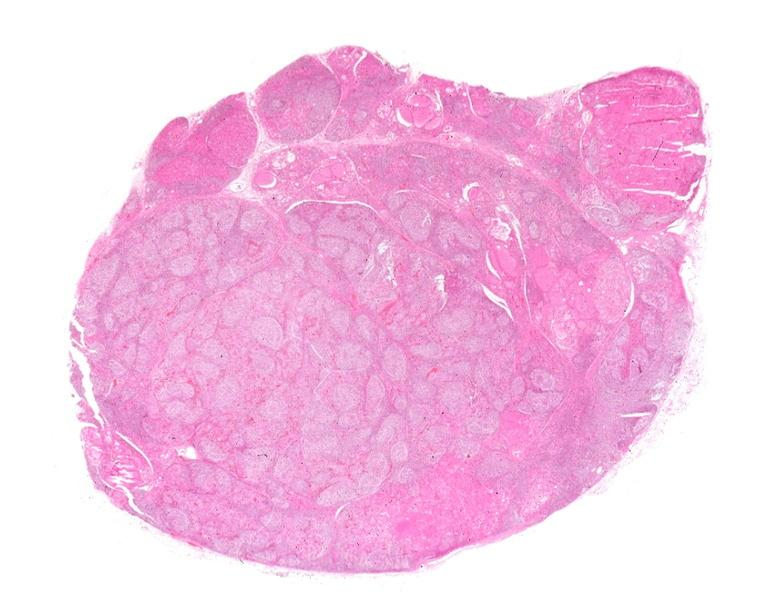s nodule present?
Answer the question using a single word or phrase. No 